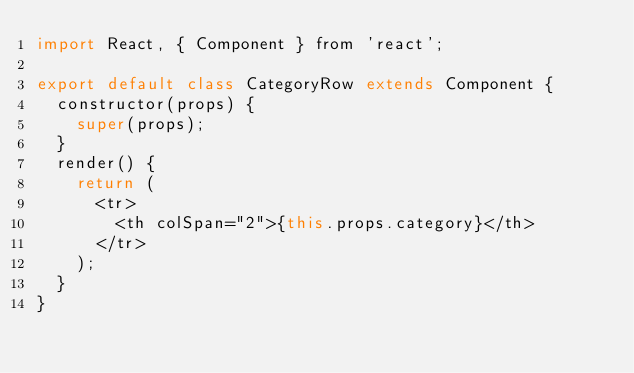Convert code to text. <code><loc_0><loc_0><loc_500><loc_500><_JavaScript_>import React, { Component } from 'react';

export default class CategoryRow extends Component {
  constructor(props) {
    super(props);
  }
  render() {
    return (
      <tr>
        <th colSpan="2">{this.props.category}</th>
      </tr>
    );
  }
}
</code> 